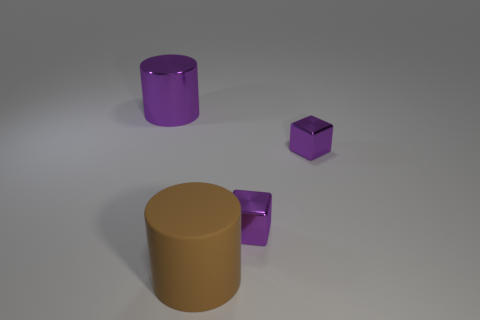Are there an equal number of brown rubber things that are on the right side of the large brown object and big objects?
Make the answer very short. No. How many other objects are there of the same color as the big matte thing?
Make the answer very short. 0. Is the number of large cylinders behind the big purple thing less than the number of tiny blocks?
Give a very brief answer. Yes. Is there a purple metal thing that has the same size as the brown rubber cylinder?
Keep it short and to the point. Yes. There is a big metal thing; is it the same color as the big cylinder on the right side of the metallic cylinder?
Make the answer very short. No. There is a large cylinder that is right of the big metallic cylinder; what number of cubes are on the right side of it?
Make the answer very short. 2. There is a shiny object that is on the left side of the cylinder that is right of the big metallic cylinder; what color is it?
Provide a short and direct response. Purple. Are there any brown matte objects that have the same shape as the big purple object?
Offer a terse response. Yes. Does the big thing in front of the purple shiny cylinder have the same shape as the big purple thing?
Provide a succinct answer. Yes. How many objects are in front of the big purple cylinder and behind the brown thing?
Your answer should be very brief. 2. 